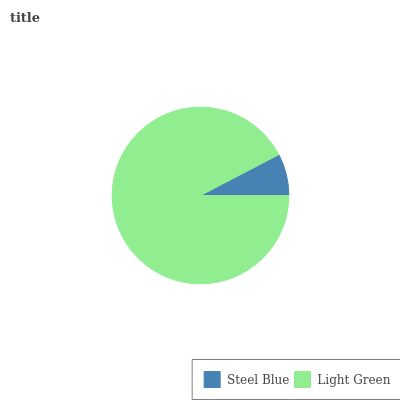Is Steel Blue the minimum?
Answer yes or no. Yes. Is Light Green the maximum?
Answer yes or no. Yes. Is Light Green the minimum?
Answer yes or no. No. Is Light Green greater than Steel Blue?
Answer yes or no. Yes. Is Steel Blue less than Light Green?
Answer yes or no. Yes. Is Steel Blue greater than Light Green?
Answer yes or no. No. Is Light Green less than Steel Blue?
Answer yes or no. No. Is Light Green the high median?
Answer yes or no. Yes. Is Steel Blue the low median?
Answer yes or no. Yes. Is Steel Blue the high median?
Answer yes or no. No. Is Light Green the low median?
Answer yes or no. No. 